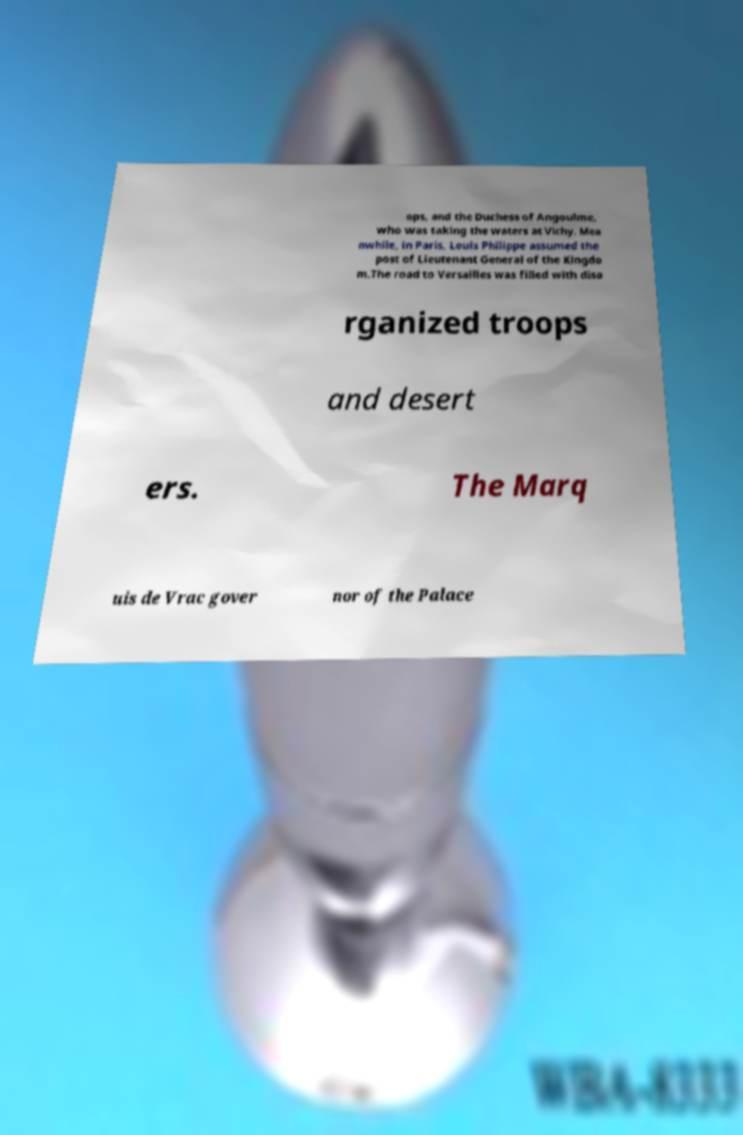Please read and relay the text visible in this image. What does it say? ops, and the Duchess of Angoulme, who was taking the waters at Vichy. Mea nwhile, in Paris, Louis Philippe assumed the post of Lieutenant General of the Kingdo m.The road to Versailles was filled with diso rganized troops and desert ers. The Marq uis de Vrac gover nor of the Palace 